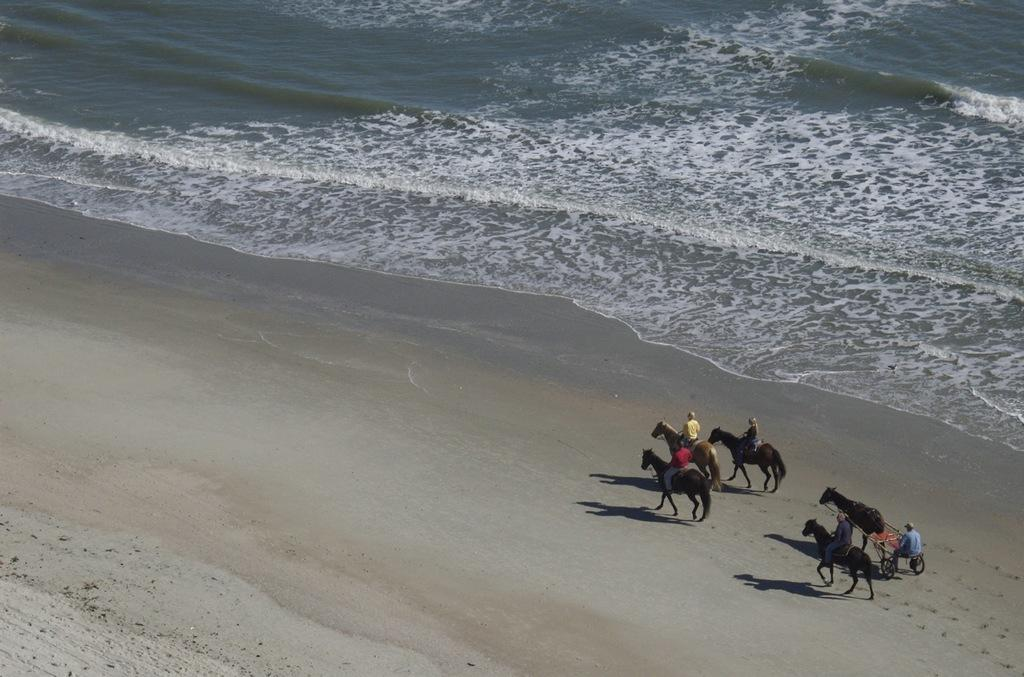What type of location is shown in the image? The image depicts a beach. What can be seen in the background of the image? There is water visible at the top of the image. What activities are people engaged in on the right side of the image? There are people riding horses on the right side of the image. What other vehicle is present on the right side of the image? There is a horse cart on the right side of the image. Where can you find icicles on the beach in the image? There are no icicles present on the beach in the image, as it is a warm location. 